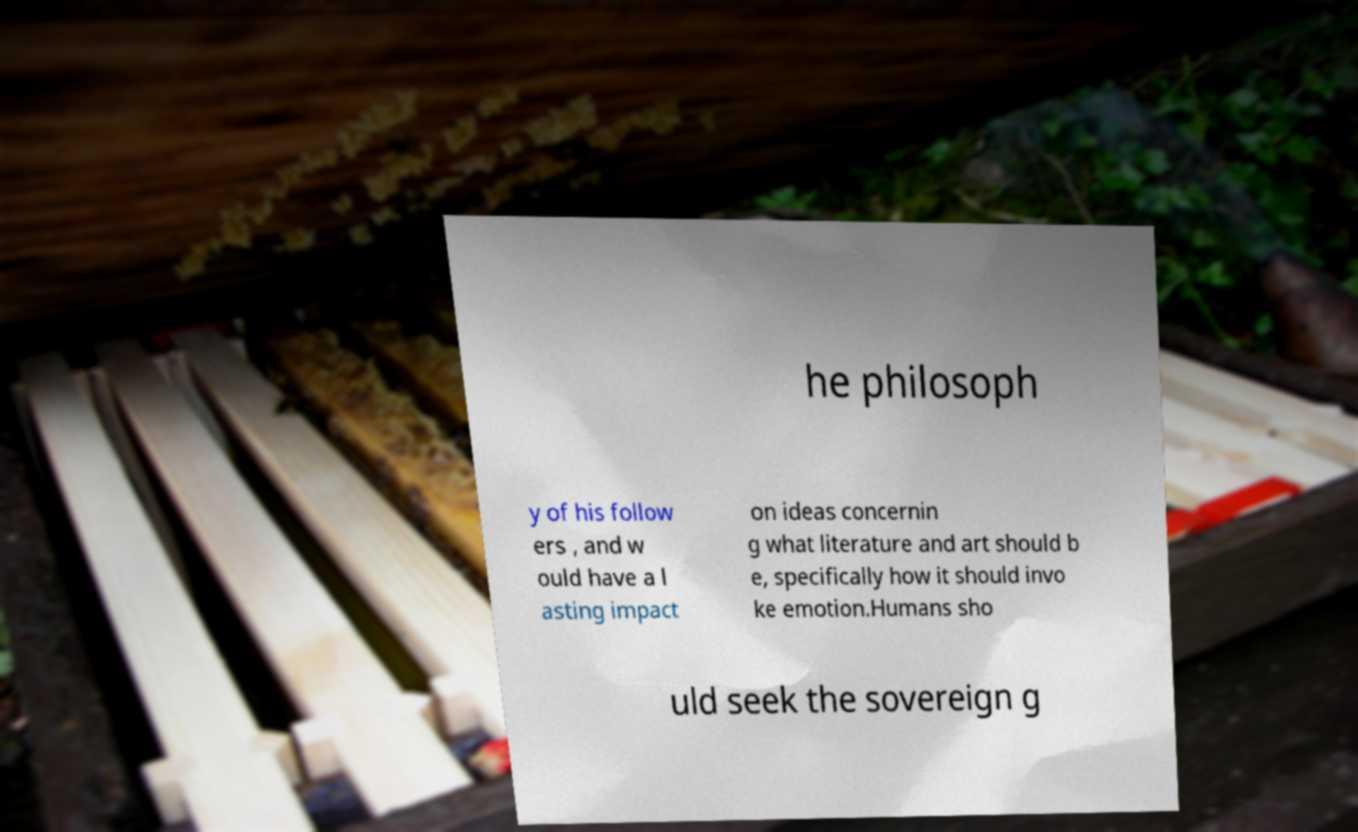For documentation purposes, I need the text within this image transcribed. Could you provide that? he philosoph y of his follow ers , and w ould have a l asting impact on ideas concernin g what literature and art should b e, specifically how it should invo ke emotion.Humans sho uld seek the sovereign g 